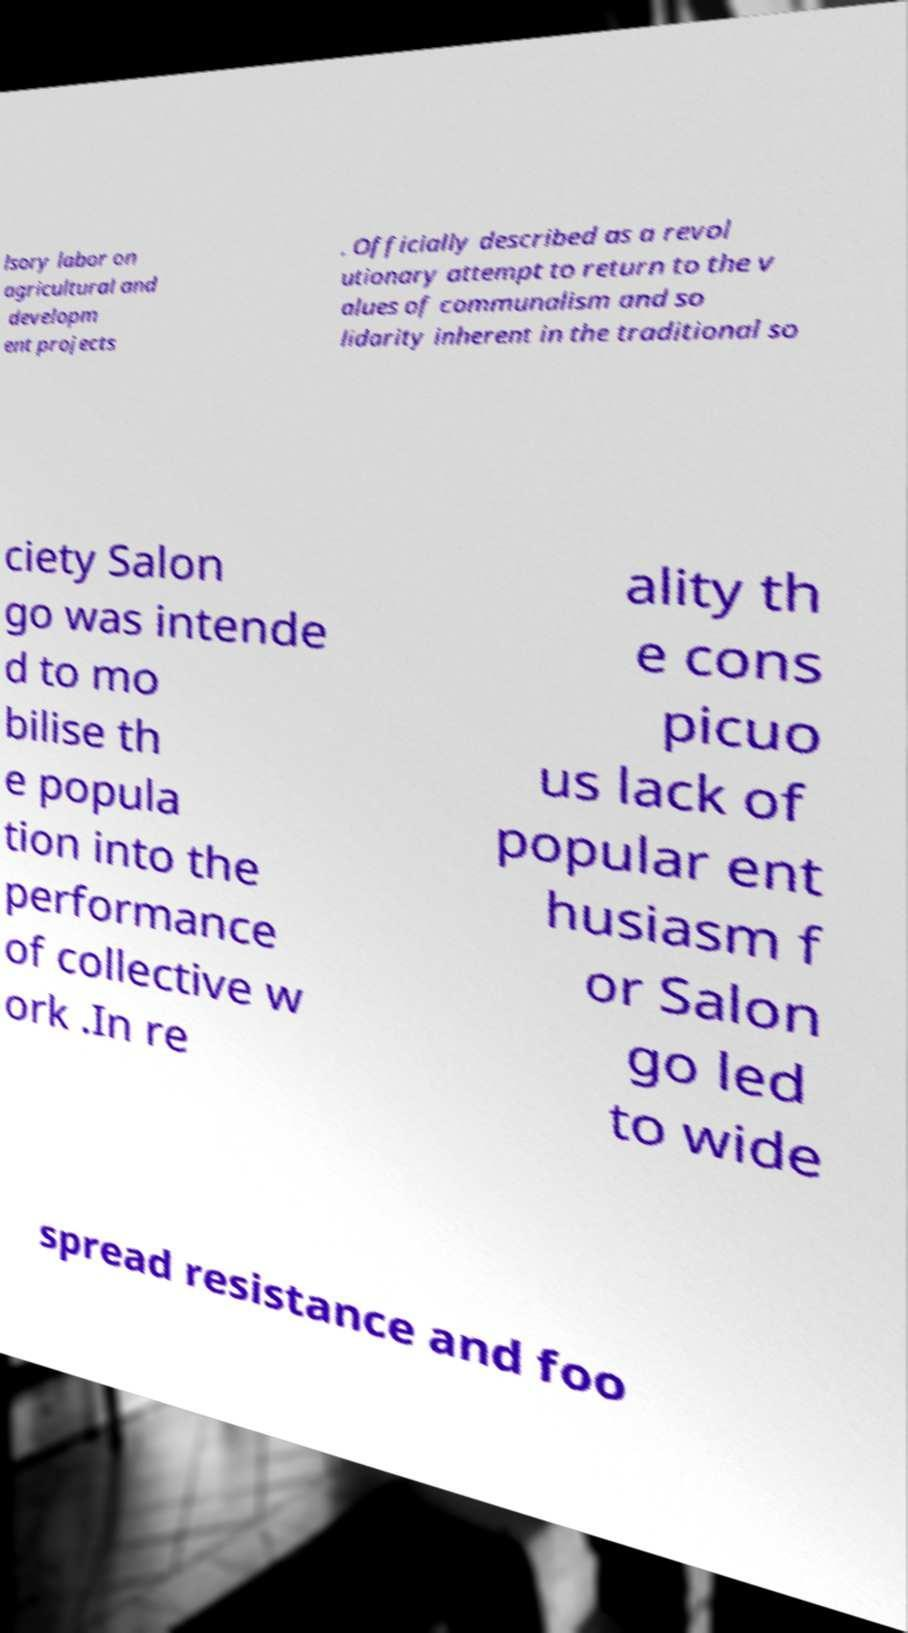Can you read and provide the text displayed in the image?This photo seems to have some interesting text. Can you extract and type it out for me? lsory labor on agricultural and developm ent projects . Officially described as a revol utionary attempt to return to the v alues of communalism and so lidarity inherent in the traditional so ciety Salon go was intende d to mo bilise th e popula tion into the performance of collective w ork .In re ality th e cons picuo us lack of popular ent husiasm f or Salon go led to wide spread resistance and foo 